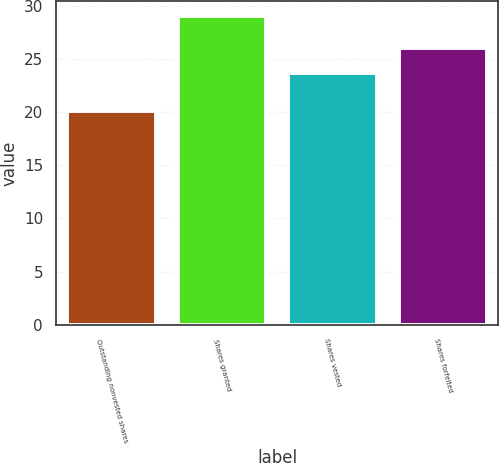Convert chart to OTSL. <chart><loc_0><loc_0><loc_500><loc_500><bar_chart><fcel>Outstanding nonvested shares<fcel>Shares granted<fcel>Shares vested<fcel>Shares forfeited<nl><fcel>20.12<fcel>28.99<fcel>23.7<fcel>26.03<nl></chart> 